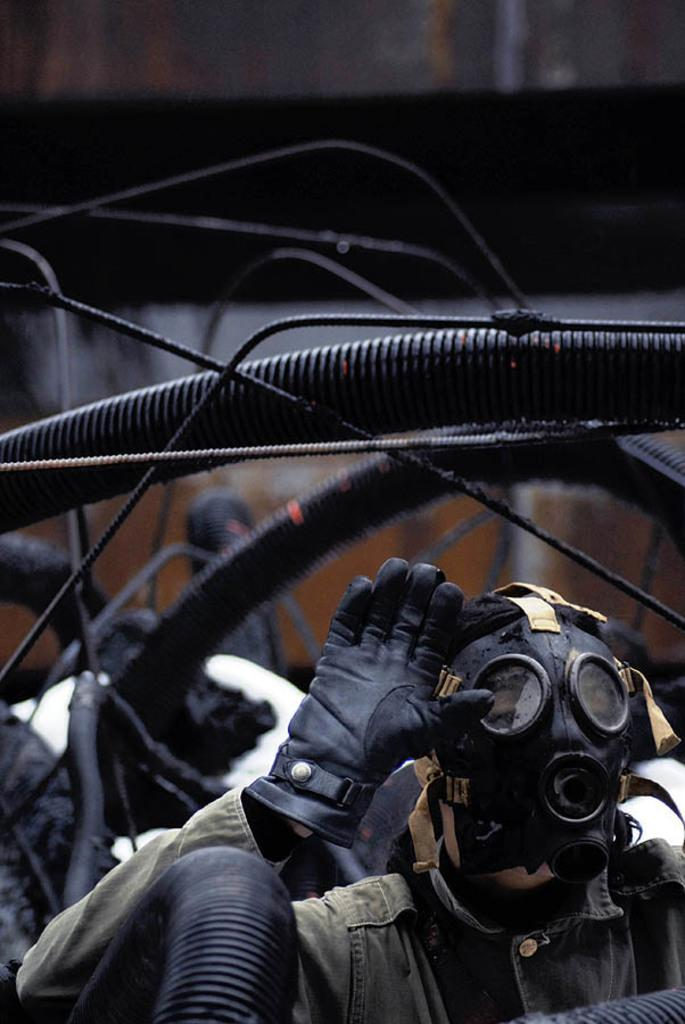What can be seen in the image related to a person? There is a person in the image. What protective gear is the person wearing? The person is wearing a mask and gloves. What objects can be seen in the image that are not related to the person? There are metal rods in the image. What type of cake is being served on the sign in the image? There is no cake or sign present in the image. How many corks are visible in the image? There are no corks visible in the image. 